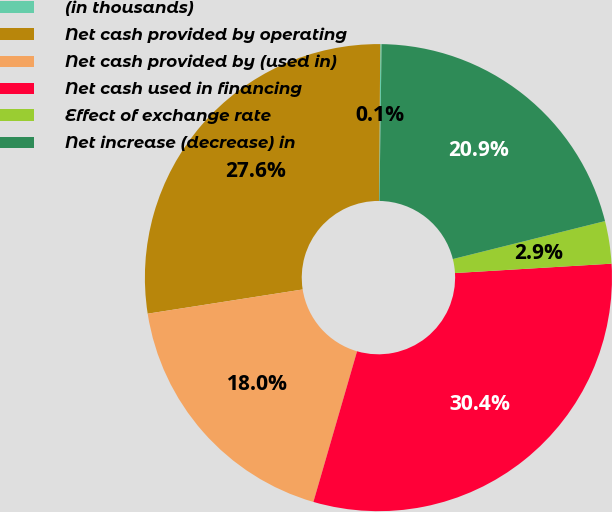Convert chart to OTSL. <chart><loc_0><loc_0><loc_500><loc_500><pie_chart><fcel>(in thousands)<fcel>Net cash provided by operating<fcel>Net cash provided by (used in)<fcel>Net cash used in financing<fcel>Effect of exchange rate<fcel>Net increase (decrease) in<nl><fcel>0.09%<fcel>27.59%<fcel>18.04%<fcel>30.44%<fcel>2.94%<fcel>20.89%<nl></chart> 